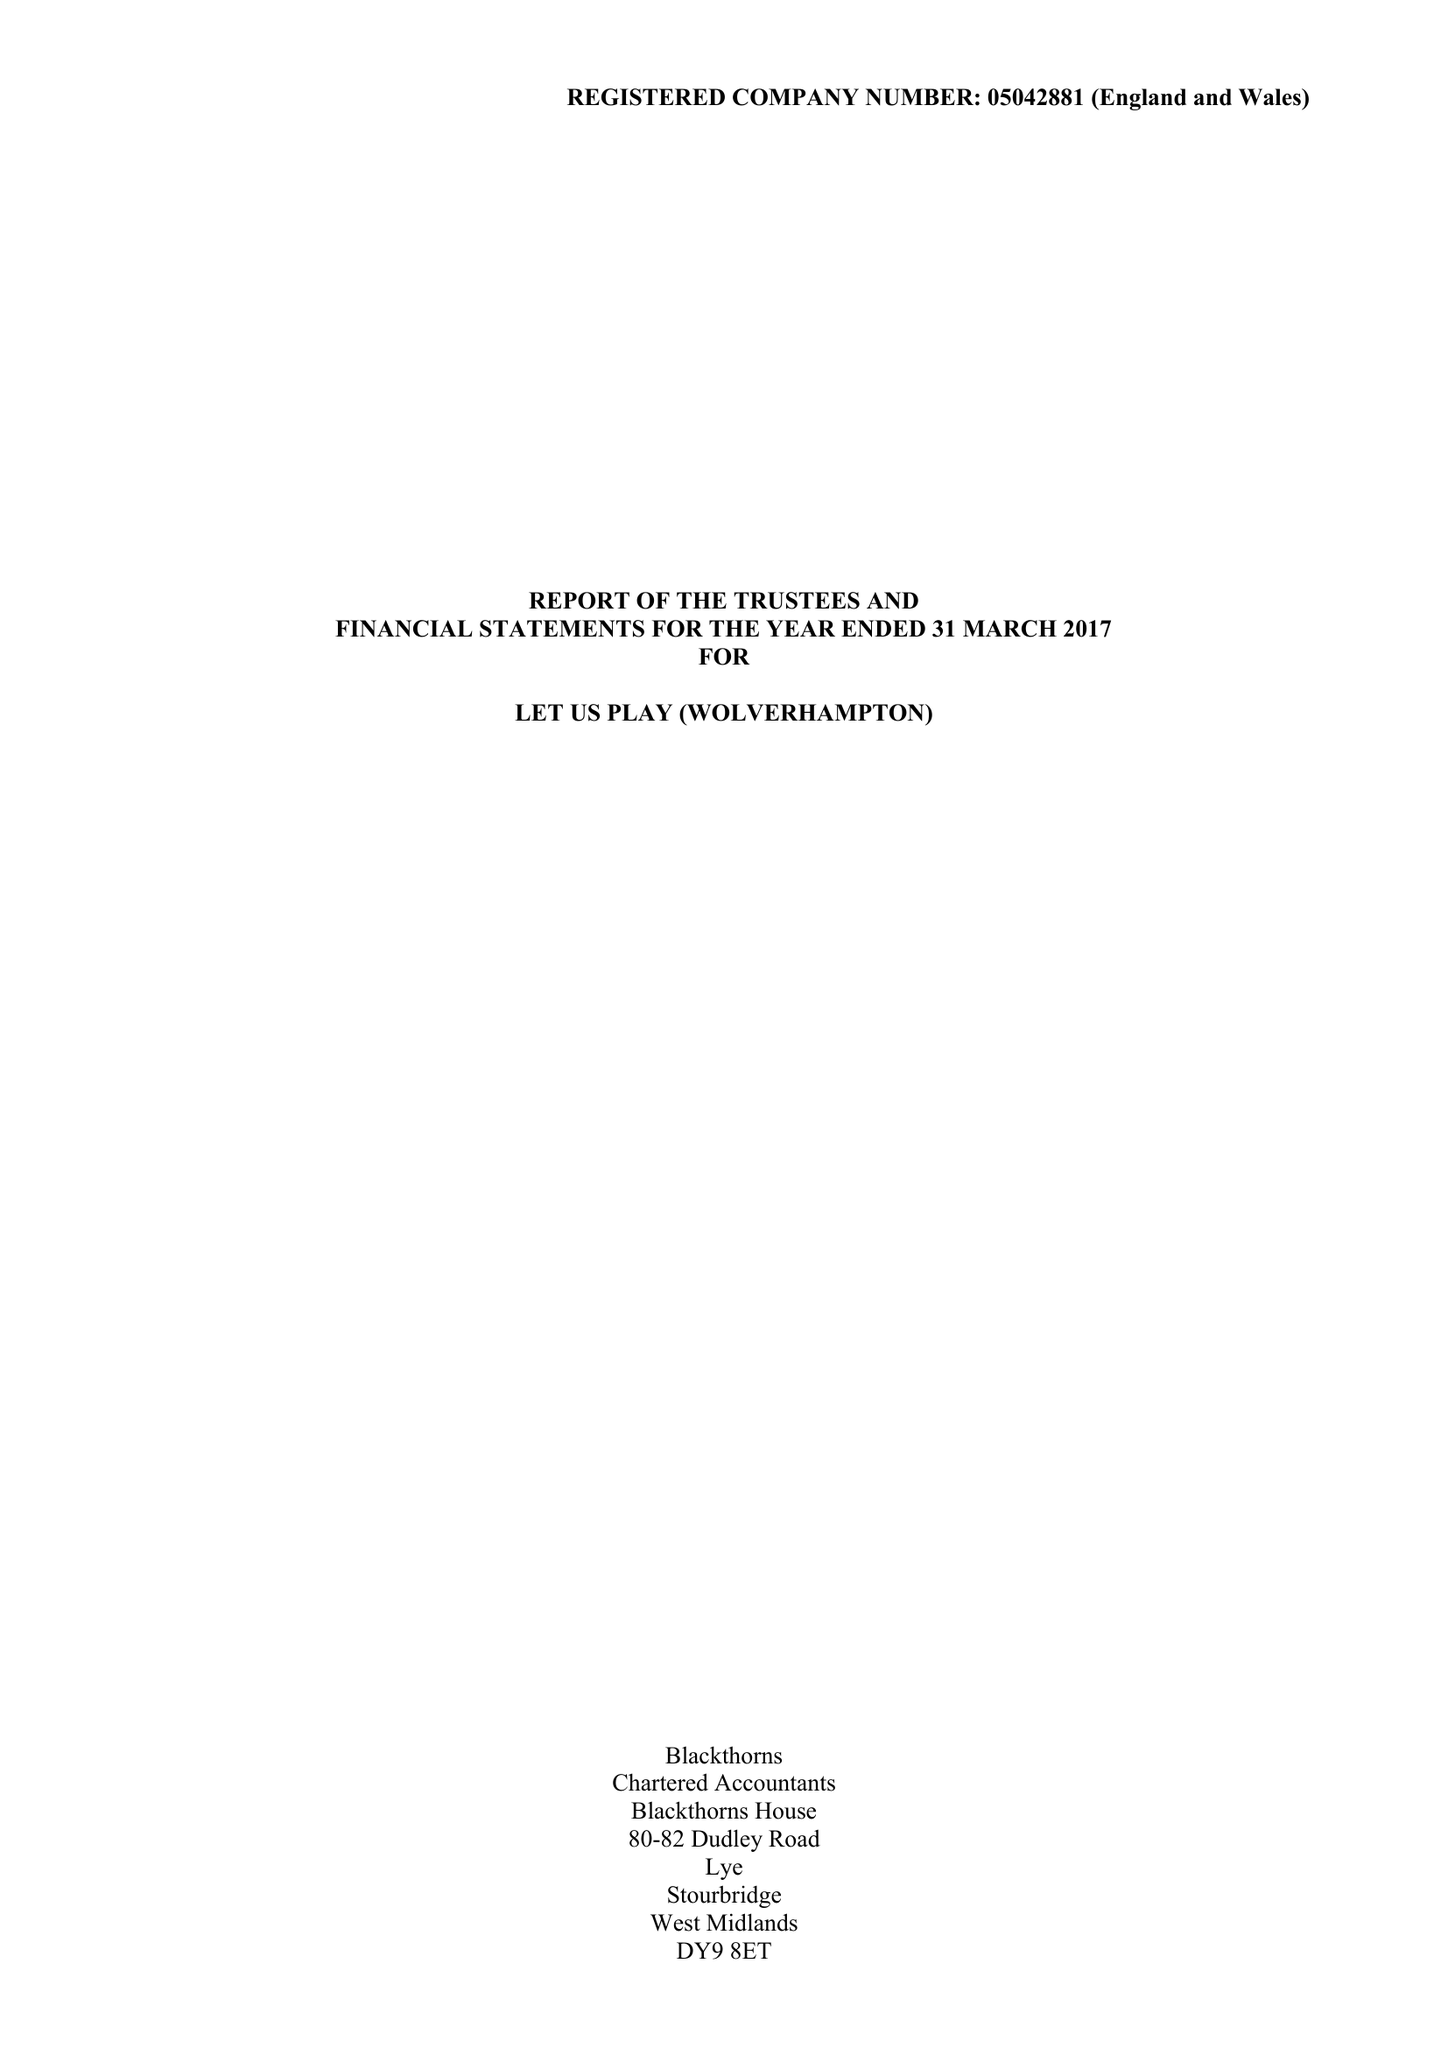What is the value for the address__street_line?
Answer the question using a single word or phrase. SHAW ROAD 